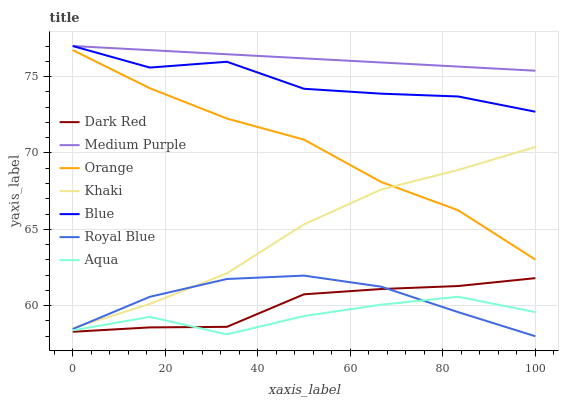Does Aqua have the minimum area under the curve?
Answer yes or no. Yes. Does Medium Purple have the maximum area under the curve?
Answer yes or no. Yes. Does Khaki have the minimum area under the curve?
Answer yes or no. No. Does Khaki have the maximum area under the curve?
Answer yes or no. No. Is Medium Purple the smoothest?
Answer yes or no. Yes. Is Aqua the roughest?
Answer yes or no. Yes. Is Khaki the smoothest?
Answer yes or no. No. Is Khaki the roughest?
Answer yes or no. No. Does Royal Blue have the lowest value?
Answer yes or no. Yes. Does Khaki have the lowest value?
Answer yes or no. No. Does Medium Purple have the highest value?
Answer yes or no. Yes. Does Khaki have the highest value?
Answer yes or no. No. Is Orange less than Blue?
Answer yes or no. Yes. Is Medium Purple greater than Aqua?
Answer yes or no. Yes. Does Royal Blue intersect Khaki?
Answer yes or no. Yes. Is Royal Blue less than Khaki?
Answer yes or no. No. Is Royal Blue greater than Khaki?
Answer yes or no. No. Does Orange intersect Blue?
Answer yes or no. No. 